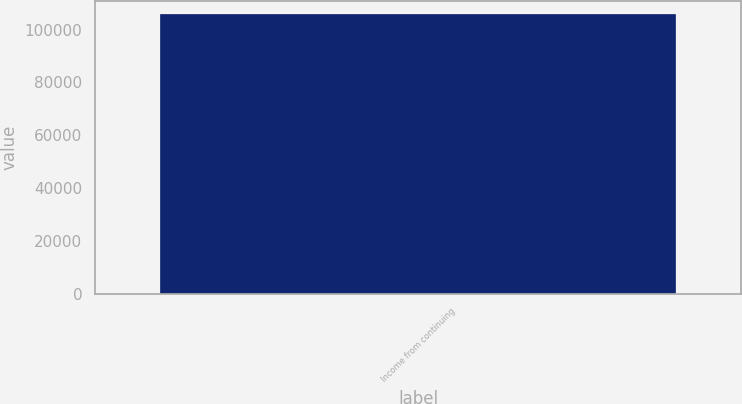<chart> <loc_0><loc_0><loc_500><loc_500><bar_chart><fcel>Income from continuing<nl><fcel>105760<nl></chart> 